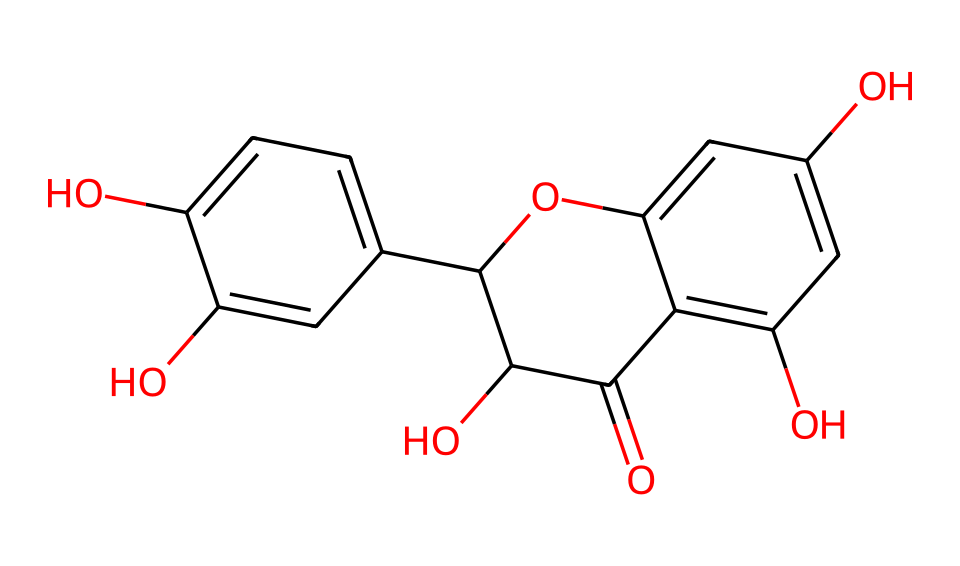What is the molecular weight of quercetin? To determine the molecular weight, we calculate the sum of the atomic weights of all atoms in the quercetin structure as represented by the SMILES. The molecular weight of quercetin is approximately 302.24 g/mol.
Answer: 302.24 g/mol How many hydroxyl (-OH) groups are present in this structure? By analyzing the structural formula derived from the SMILES representation, we identify the hydroxyl groups, each represented by an –OH. The quercetin structure contains five hydroxyl groups.
Answer: 5 What is the main type of chemical bonding in quercetin? The primary type of bonding present in quercetin is covalent bonding, as it consists mainly of carbon-hydrogen and carbon-oxygen bonds throughout its structure.
Answer: covalent Which part of the quercetin structure is responsible for its antioxidant properties? The flavonoid structure, particularly the presence of multiple hydroxyl groups, contributes significantly to its antioxidant properties due to their ability to donate hydrogen atoms, thus neutralizing free radicals.
Answer: flavonoid structure What is the number of carbon atoms in quercetin? To answer this, we identify and count the carbon atoms depicted in the chemical structure based on the SMILES notation, which reveals there are 15 carbon atoms in quercetin.
Answer: 15 What type of compound is quercetin classified as? Quercetin is classified as a flavonoid, which is a specific class of polyphenolic compounds known for their antioxidant effects and health benefits.
Answer: flavonoid 